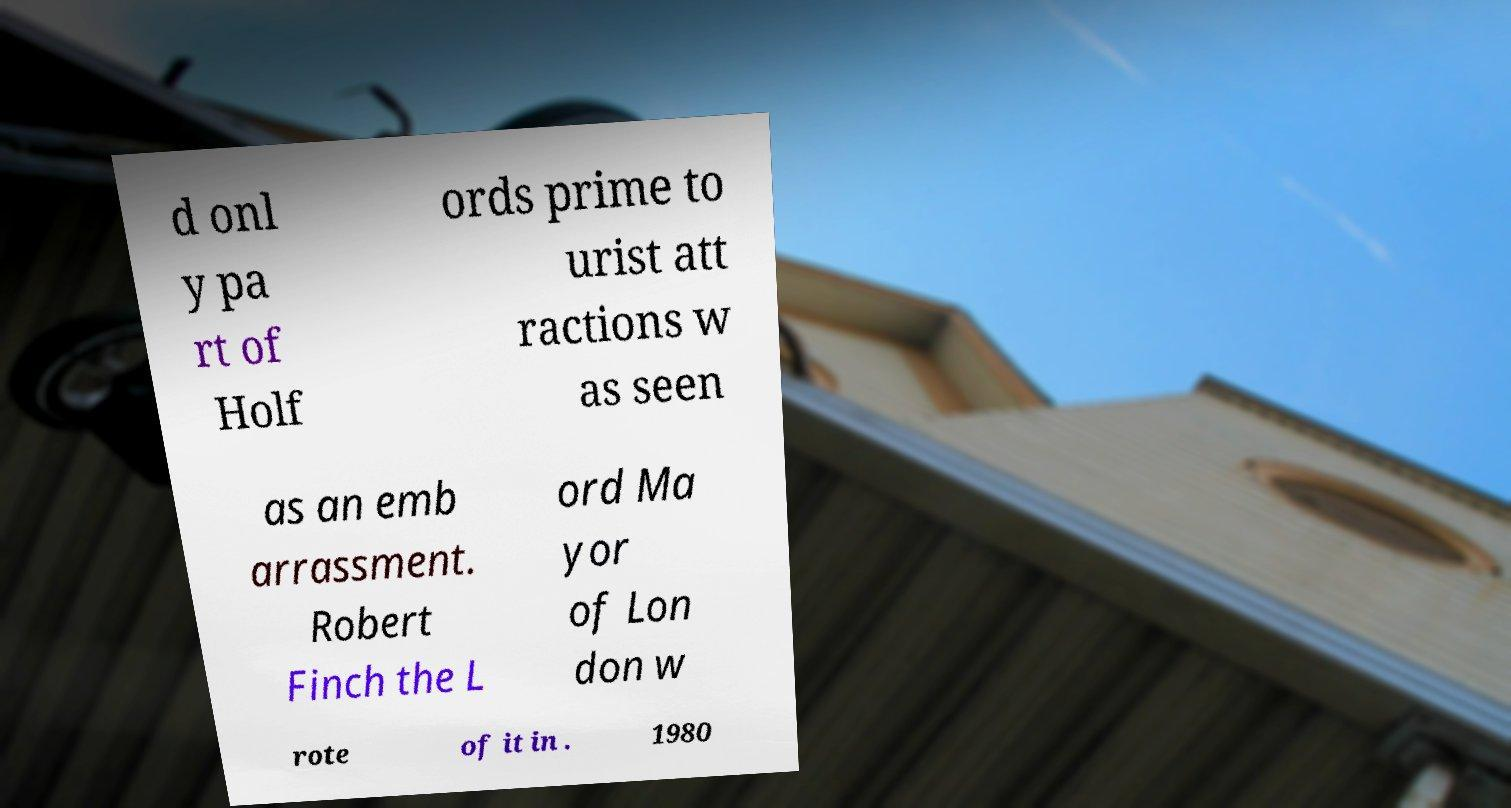What messages or text are displayed in this image? I need them in a readable, typed format. d onl y pa rt of Holf ords prime to urist att ractions w as seen as an emb arrassment. Robert Finch the L ord Ma yor of Lon don w rote of it in . 1980 